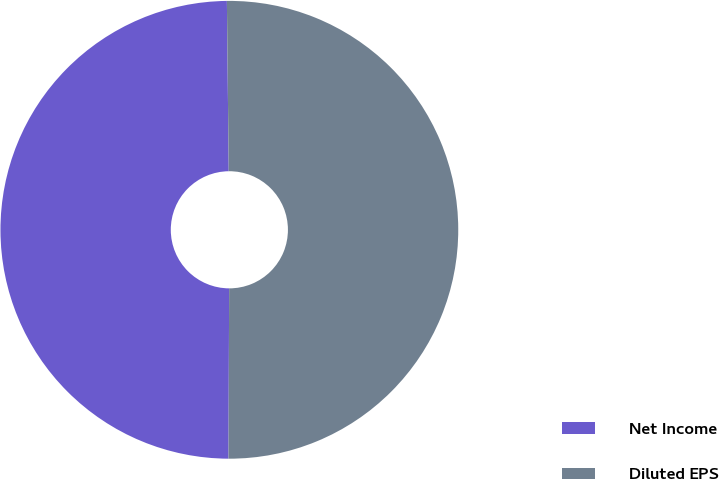Convert chart to OTSL. <chart><loc_0><loc_0><loc_500><loc_500><pie_chart><fcel>Net Income<fcel>Diluted EPS<nl><fcel>49.77%<fcel>50.23%<nl></chart> 